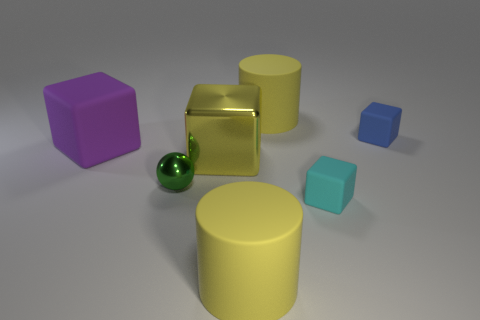Subtract all purple blocks. How many blocks are left? 3 Add 1 big purple rubber cubes. How many objects exist? 8 Subtract all cyan cubes. How many cubes are left? 3 Subtract all cubes. How many objects are left? 3 Subtract all purple balls. Subtract all brown cylinders. How many balls are left? 1 Subtract all tiny green metallic things. Subtract all cyan matte cubes. How many objects are left? 5 Add 7 purple things. How many purple things are left? 8 Add 6 purple matte cylinders. How many purple matte cylinders exist? 6 Subtract 0 gray cylinders. How many objects are left? 7 